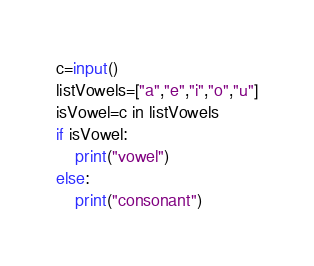Convert code to text. <code><loc_0><loc_0><loc_500><loc_500><_Python_>c=input()
listVowels=["a","e","i","o","u"]
isVowel=c in listVowels
if isVowel:
    print("vowel")
else:
    print("consonant")</code> 